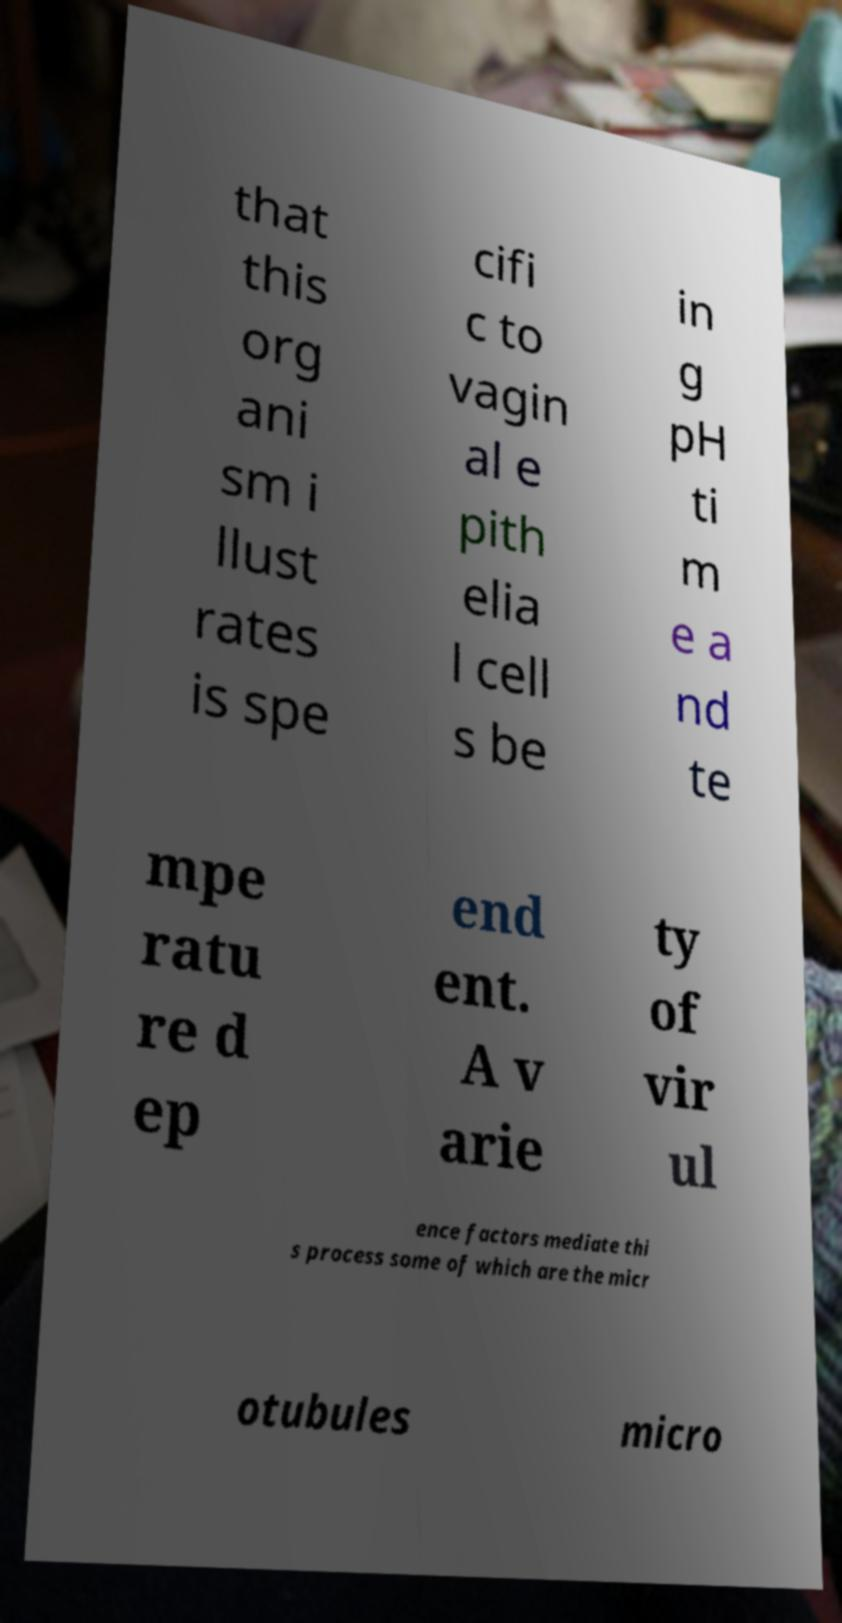Can you accurately transcribe the text from the provided image for me? that this org ani sm i llust rates is spe cifi c to vagin al e pith elia l cell s be in g pH ti m e a nd te mpe ratu re d ep end ent. A v arie ty of vir ul ence factors mediate thi s process some of which are the micr otubules micro 